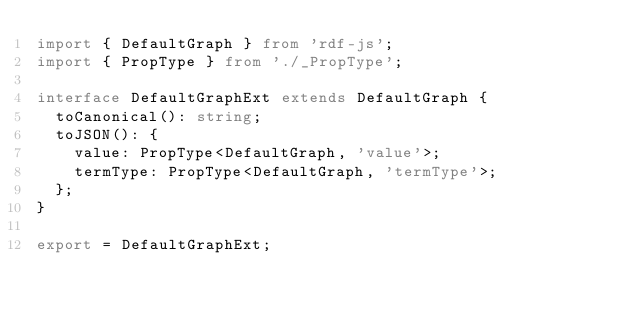<code> <loc_0><loc_0><loc_500><loc_500><_TypeScript_>import { DefaultGraph } from 'rdf-js';
import { PropType } from './_PropType';

interface DefaultGraphExt extends DefaultGraph {
  toCanonical(): string;
  toJSON(): {
    value: PropType<DefaultGraph, 'value'>;
    termType: PropType<DefaultGraph, 'termType'>;
  };
}

export = DefaultGraphExt;
</code> 